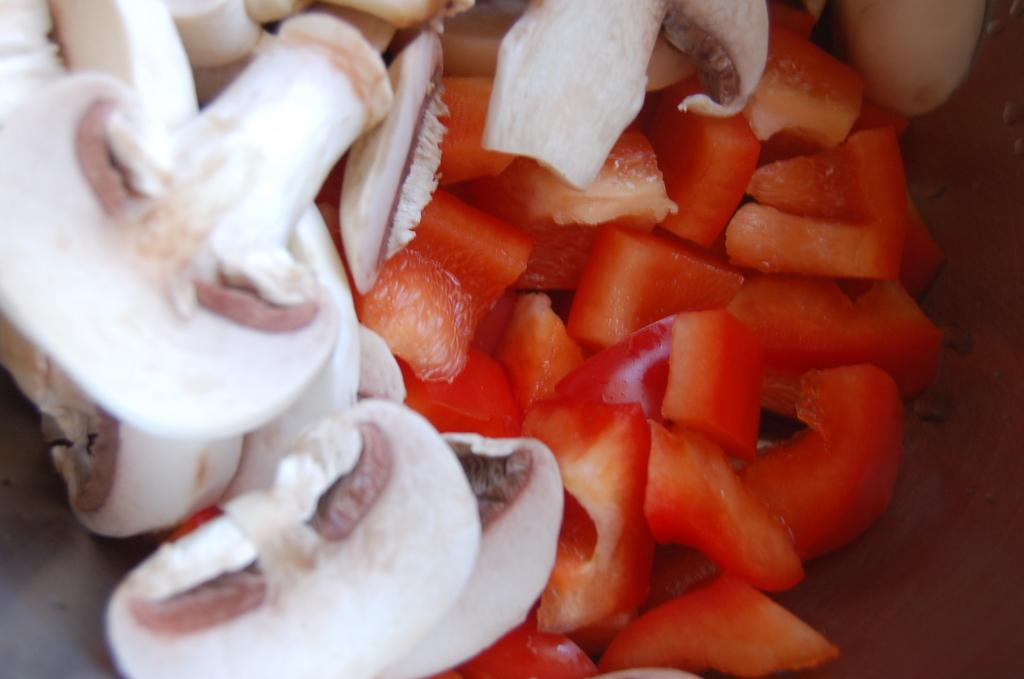What type of food can be seen on the right side of the image? There are slices of a vegetable on the right side of the image. What type of fungi is present on the left side of the image? There is a mushroom on the left side of the image. How many fingers can be seen pointing at the mushroom in the image? There are no fingers visible in the image, as it only features vegetable slices and a mushroom. 